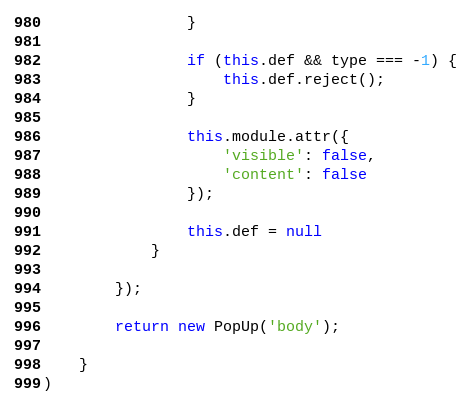<code> <loc_0><loc_0><loc_500><loc_500><_JavaScript_>                }

                if (this.def && type === -1) {
                    this.def.reject();
                }

                this.module.attr({
                    'visible': false,
                    'content': false
                });

                this.def = null
            }

        });

        return new PopUp('body');

    }
)
</code> 